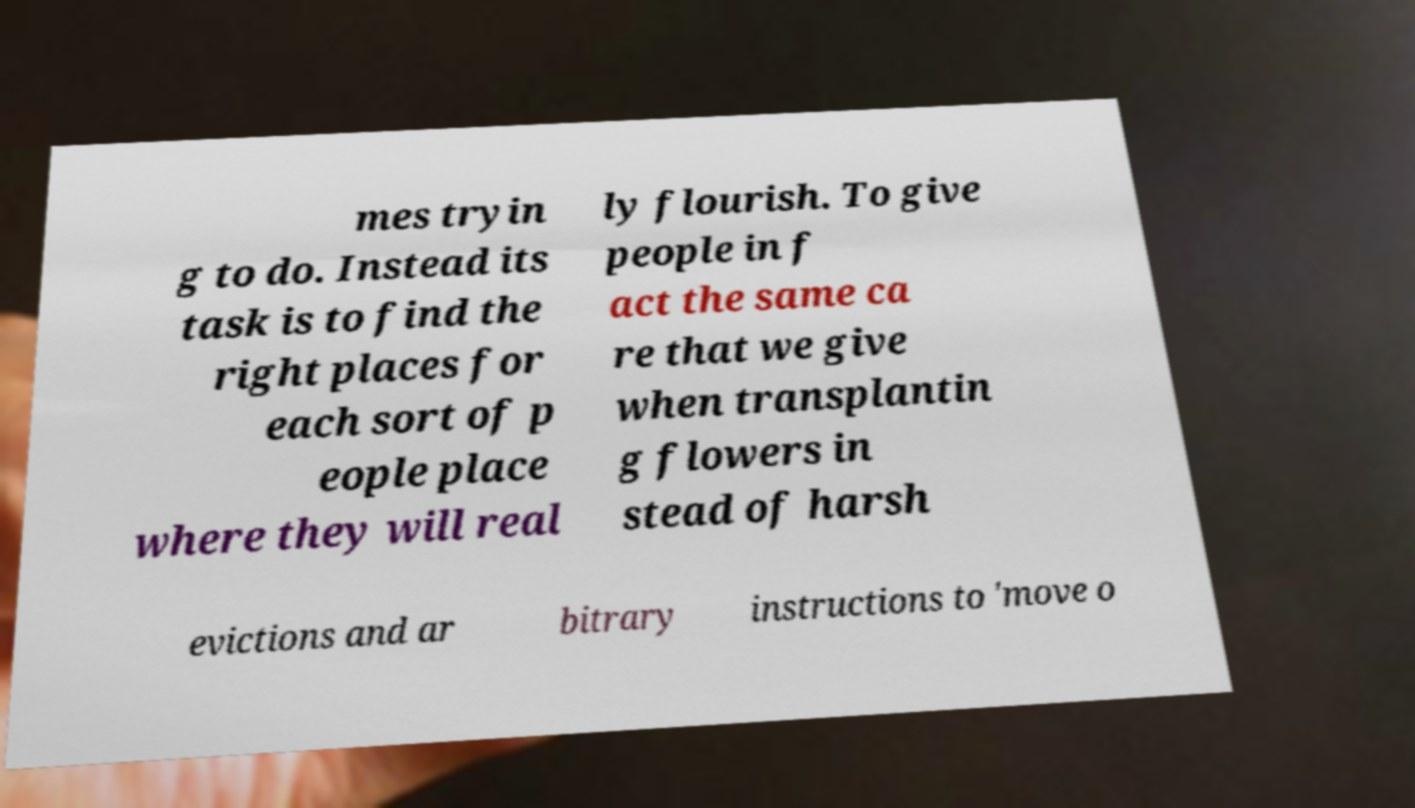There's text embedded in this image that I need extracted. Can you transcribe it verbatim? mes tryin g to do. Instead its task is to find the right places for each sort of p eople place where they will real ly flourish. To give people in f act the same ca re that we give when transplantin g flowers in stead of harsh evictions and ar bitrary instructions to 'move o 